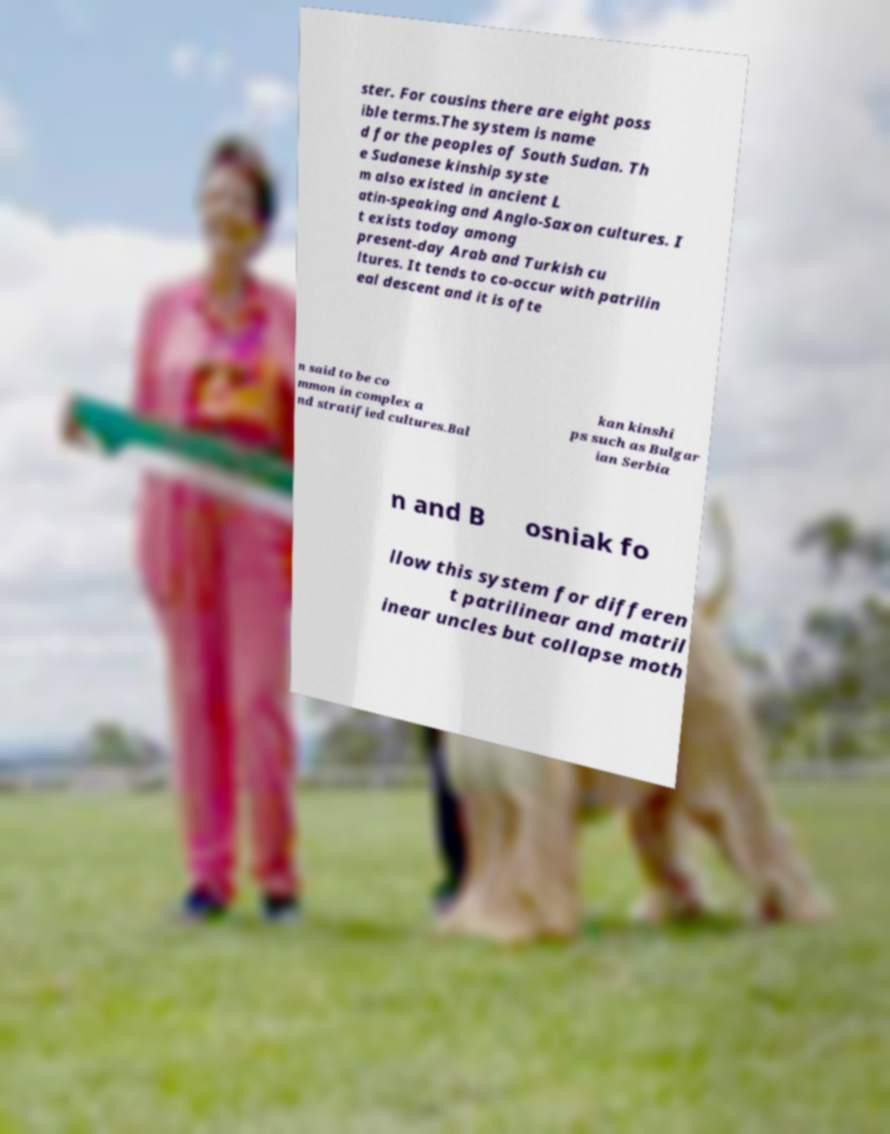Can you accurately transcribe the text from the provided image for me? ster. For cousins there are eight poss ible terms.The system is name d for the peoples of South Sudan. Th e Sudanese kinship syste m also existed in ancient L atin-speaking and Anglo-Saxon cultures. I t exists today among present-day Arab and Turkish cu ltures. It tends to co-occur with patrilin eal descent and it is ofte n said to be co mmon in complex a nd stratified cultures.Bal kan kinshi ps such as Bulgar ian Serbia n and B osniak fo llow this system for differen t patrilinear and matril inear uncles but collapse moth 